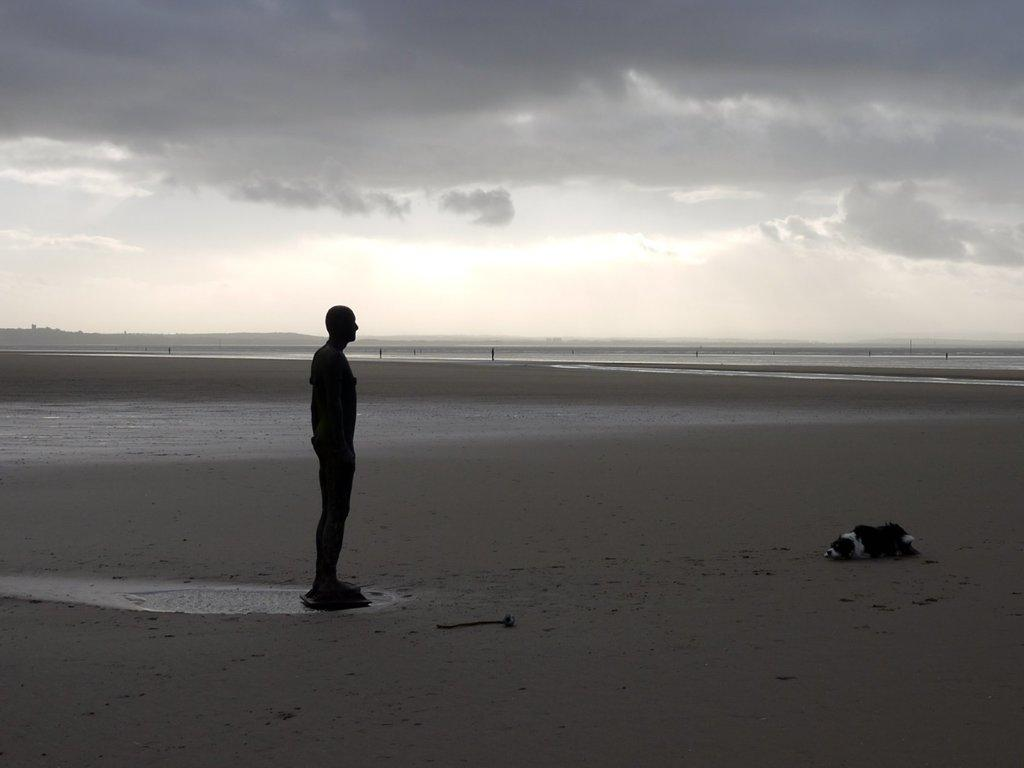What is the main subject of the image? There is a person standing on the beach in the image. What other living creature can be seen in the image? There is a dog in the image. What natural feature is present in the background of the image? The image contains the sea. How would you describe the weather based on the image? The sky is cloudy in the image. What type of behavior is the minister exhibiting in the image? There is no minister present in the image, so it is not possible to comment on their behavior. 